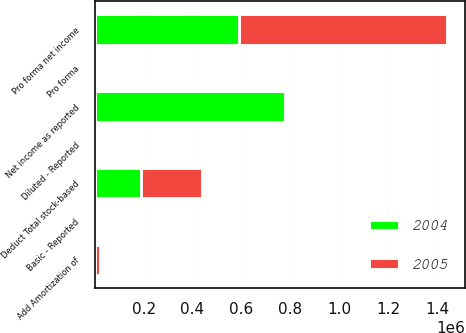Convert chart to OTSL. <chart><loc_0><loc_0><loc_500><loc_500><stacked_bar_chart><ecel><fcel>Net income as reported<fcel>Add Amortization of<fcel>Deduct Total stock-based<fcel>Pro forma net income<fcel>Basic - Reported<fcel>Pro forma<fcel>Diluted - Reported<nl><fcel>2004<fcel>778223<fcel>1715<fcel>190935<fcel>589003<fcel>0.59<fcel>0.45<fcel>0.57<nl><fcel>2005<fcel>1715<fcel>18749<fcel>248260<fcel>852532<fcel>0.79<fcel>0.63<fcel>0.78<nl></chart> 